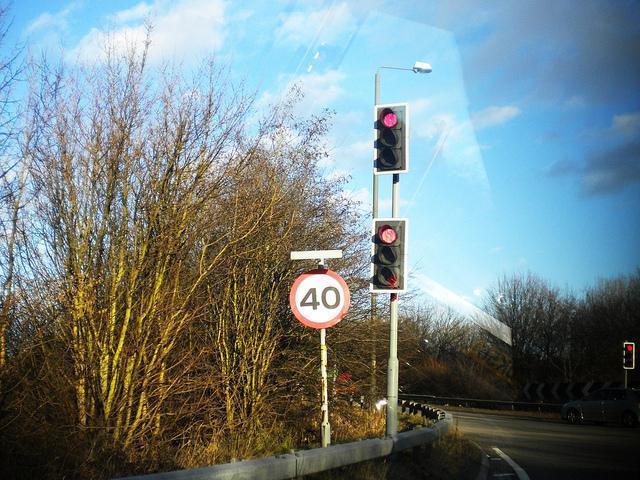How many traffic lights are there?
Give a very brief answer. 2. 